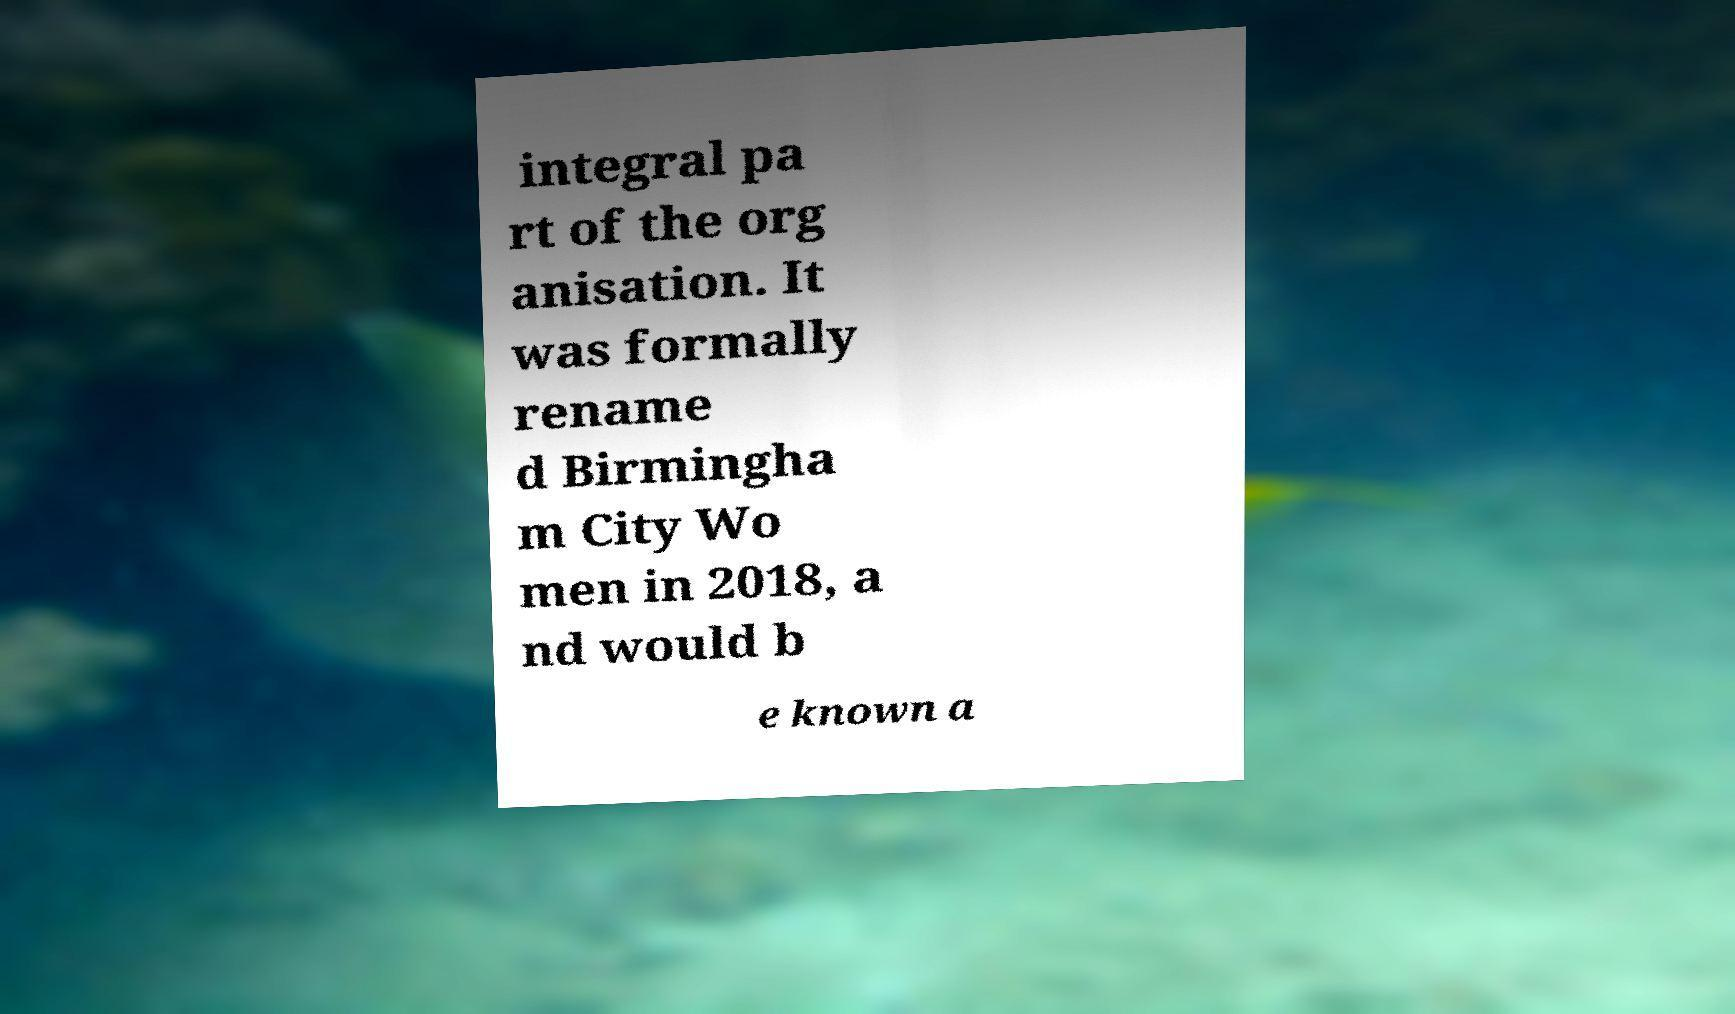There's text embedded in this image that I need extracted. Can you transcribe it verbatim? integral pa rt of the org anisation. It was formally rename d Birmingha m City Wo men in 2018, a nd would b e known a 